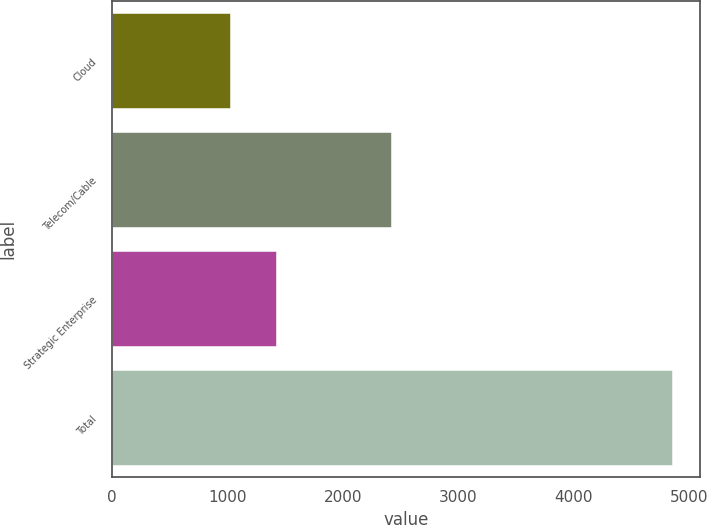Convert chart to OTSL. <chart><loc_0><loc_0><loc_500><loc_500><bar_chart><fcel>Cloud<fcel>Telecom/Cable<fcel>Strategic Enterprise<fcel>Total<nl><fcel>1021.2<fcel>2417.1<fcel>1419.5<fcel>4857.8<nl></chart> 